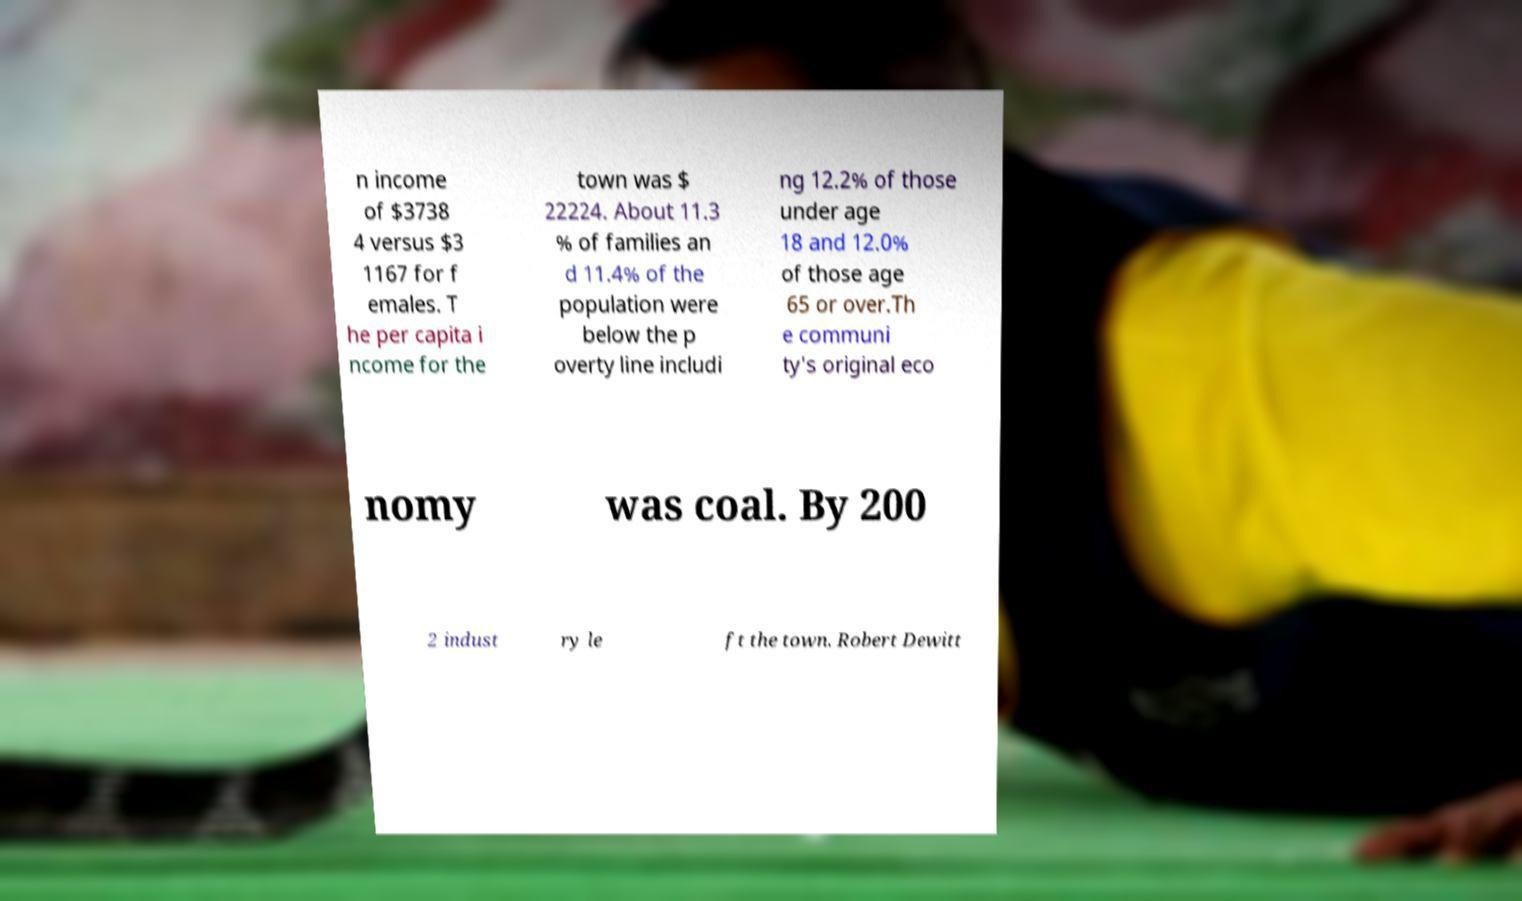For documentation purposes, I need the text within this image transcribed. Could you provide that? n income of $3738 4 versus $3 1167 for f emales. T he per capita i ncome for the town was $ 22224. About 11.3 % of families an d 11.4% of the population were below the p overty line includi ng 12.2% of those under age 18 and 12.0% of those age 65 or over.Th e communi ty's original eco nomy was coal. By 200 2 indust ry le ft the town. Robert Dewitt 